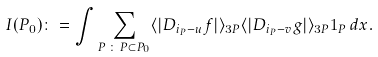Convert formula to latex. <formula><loc_0><loc_0><loc_500><loc_500>I ( P _ { 0 } ) \colon = \int \sum _ { P \, \colon \, P \subset P _ { 0 } } \langle | D _ { i _ { P } - u } f | \rangle _ { 3 P } \langle | D _ { i _ { P } - v } g | \rangle _ { 3 P } \mathbf 1 _ { P } \, d x .</formula> 